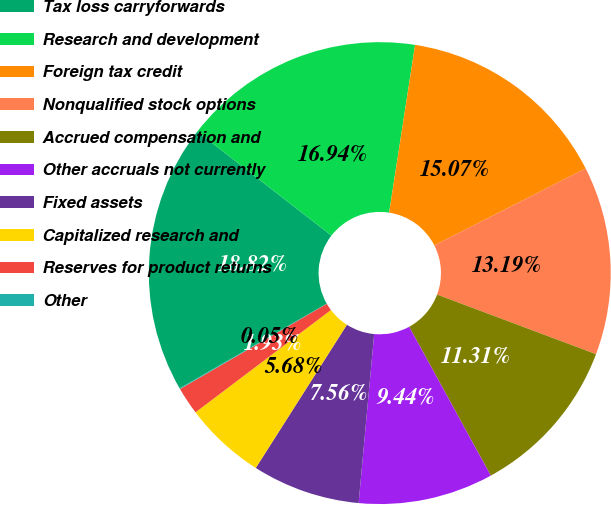Convert chart to OTSL. <chart><loc_0><loc_0><loc_500><loc_500><pie_chart><fcel>Tax loss carryforwards<fcel>Research and development<fcel>Foreign tax credit<fcel>Nonqualified stock options<fcel>Accrued compensation and<fcel>Other accruals not currently<fcel>Fixed assets<fcel>Capitalized research and<fcel>Reserves for product returns<fcel>Other<nl><fcel>18.82%<fcel>16.94%<fcel>15.07%<fcel>13.19%<fcel>11.31%<fcel>9.44%<fcel>7.56%<fcel>5.68%<fcel>1.93%<fcel>0.05%<nl></chart> 